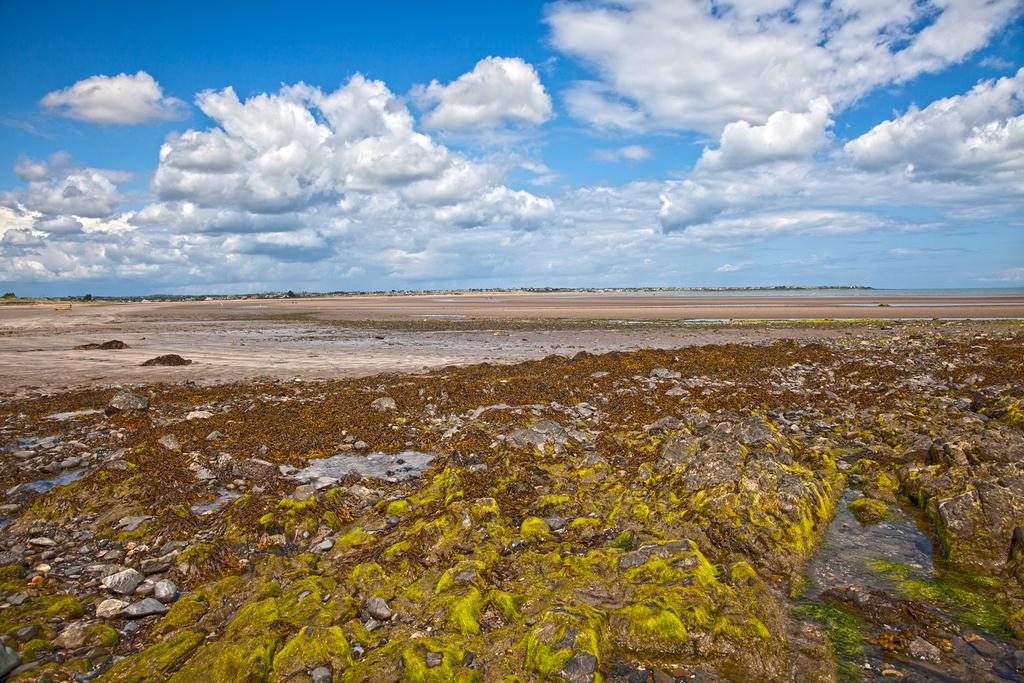What is on the ground in the image? There are stones on the ground in the image. What can be seen in the background of the image? The sky is visible in the background of the image. What is present in the sky? Clouds are present in the sky. What type of sweater is being worn by the existence in the image? There is no existence or sweater present in the image. Can you tell me how many knives are visible in the image? There are no knives present in the image. 